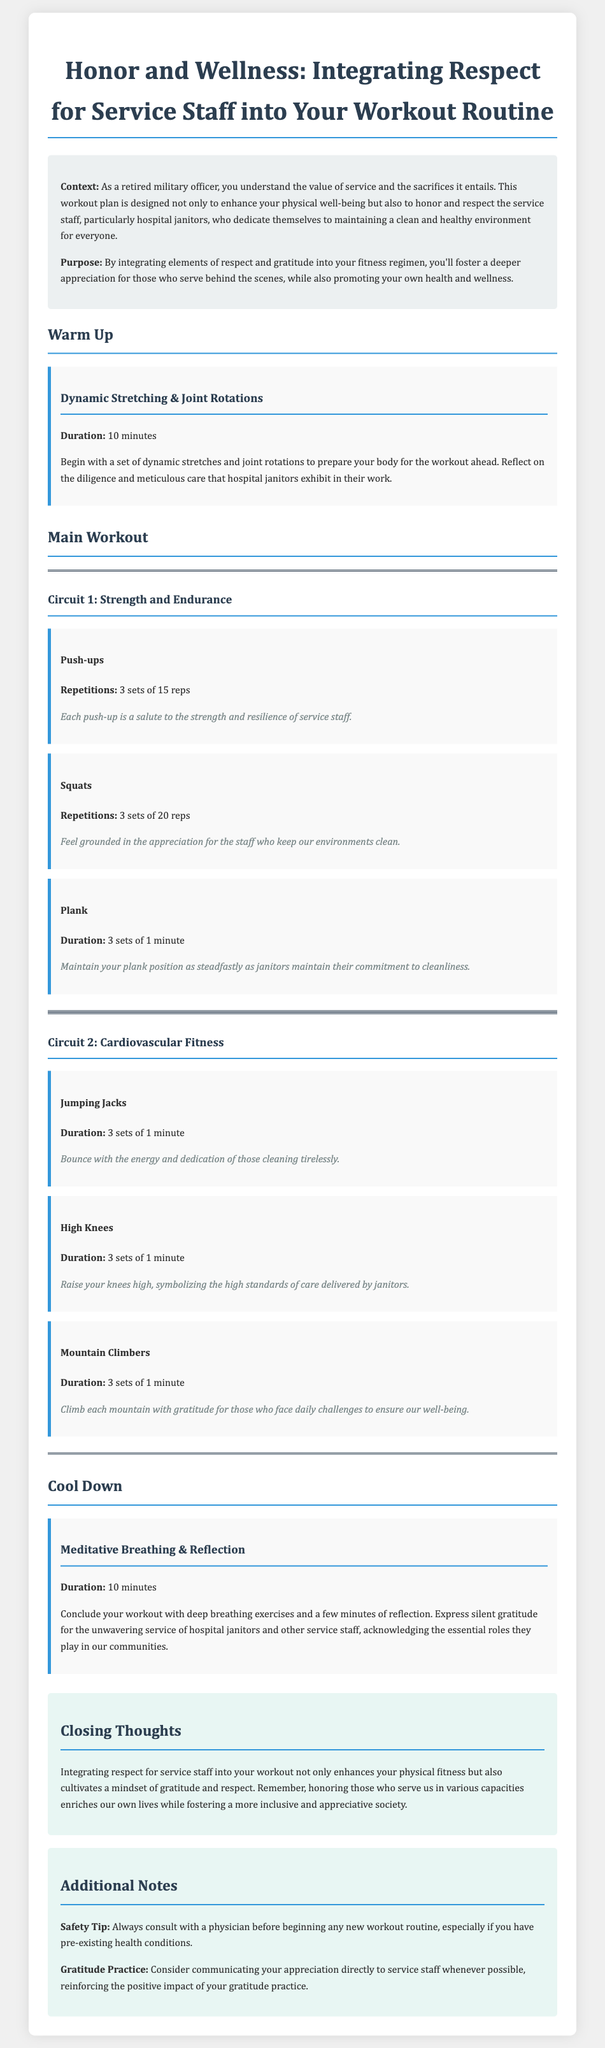What is the main purpose of the workout plan? The purpose of the workout plan is to integrate elements of respect and gratitude into your fitness regimen while promoting health and wellness.
Answer: To integrate respect and gratitude How long is the warm-up section? The duration for the warm-up section, which includes dynamic stretching and joint rotations, is mentioned in the document.
Answer: 10 minutes How many sets of push-ups are recommended? The document specifies the number of repetitions and sets for push-ups in the main workout section.
Answer: 3 sets of 15 reps Which exercise in Circuit 2 involves jumping? The exercise that explicitly includes the action of jumping is mentioned in the cardiovascular fitness section of the document.
Answer: Jumping Jacks What is encouraged after completing the workout? The document emphasizes a specific practice to conclude the workout that reflects appreciation for service staff.
Answer: Meditative Breathing & Reflection What message accompanies the squats exercise? There is a specific honoring message provided in the workout plan that accompanies the squats exercise.
Answer: Feel grounded in the appreciation for the staff who keep our environments clean What is the closing thought about honoring service staff? The document concludes with a reflection on the impact of honoring service staff on personal enrichment and society.
Answer: Honoring those who serve us enriches our own lives What safety tip is provided in the additional notes? The additional notes section contains a recommendation regarding consulting professionals before starting a new workout routine.
Answer: Consult with a physician 